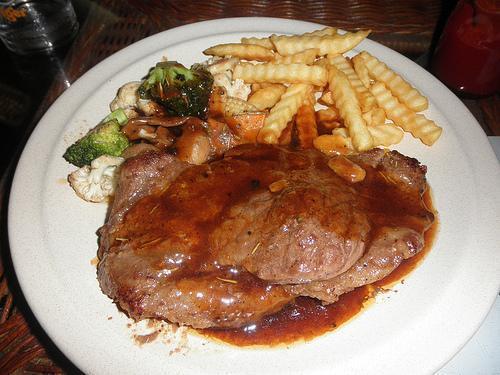How many sides are on the plate?
Give a very brief answer. 2. 